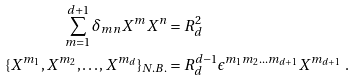Convert formula to latex. <formula><loc_0><loc_0><loc_500><loc_500>\sum _ { m = 1 } ^ { d + 1 } \delta _ { m n } X ^ { m } X ^ { n } & = R _ { d } ^ { 2 } \\ \{ X ^ { m _ { 1 } } , X ^ { m _ { 2 } } , \dots , X ^ { m _ { d } } \} _ { N . B . } & = R _ { d } ^ { d - 1 } \epsilon ^ { m _ { 1 } m _ { 2 } \dots m _ { d + 1 } } X ^ { m _ { d + 1 } } \ .</formula> 